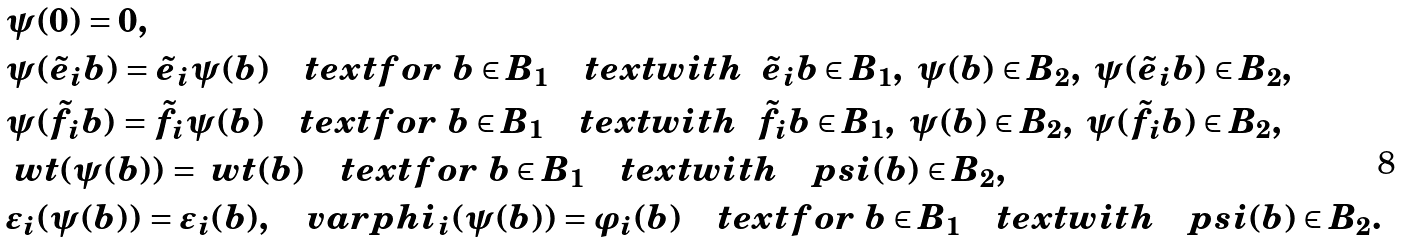Convert formula to latex. <formula><loc_0><loc_0><loc_500><loc_500>& \psi ( 0 ) = 0 , \\ & \psi ( { \tilde { e } _ { i } } b ) = \tilde { e } _ { i } \psi ( b ) \quad t e x t { f o r } \ b \in B _ { 1 } \quad t e x t { w i t h } \ \ { \tilde { e } _ { i } } b \in B _ { 1 } , \ \psi ( b ) \in B _ { 2 } , \ \psi ( \tilde { e } _ { i } b ) \in B _ { 2 } , \\ & \psi ( { \tilde { f } _ { i } } b ) = \tilde { f } _ { i } \psi ( b ) \quad t e x t { f o r } \ b \in B _ { 1 } \quad t e x t { w i t h } \ \ { \tilde { f } _ { i } } b \in B _ { 1 } , \ \psi ( b ) \in B _ { 2 } , \ \psi ( \tilde { f } _ { i } b ) \in B _ { 2 } , \\ & \ w t ( \psi ( b ) ) = \ w t ( b ) \quad t e x t { f o r } \ b \in B _ { 1 } \quad t e x t { w i t h } \quad p s i ( b ) \in B _ { 2 } , \\ & \varepsilon _ { i } ( \psi ( b ) ) = \varepsilon _ { i } ( b ) , \quad v a r p h i _ { i } ( \psi ( b ) ) = \varphi _ { i } ( b ) \quad t e x t { f o r } \ b \in B _ { 1 } \quad t e x t { w i t h } \quad p s i ( b ) \in B _ { 2 } . \\</formula> 